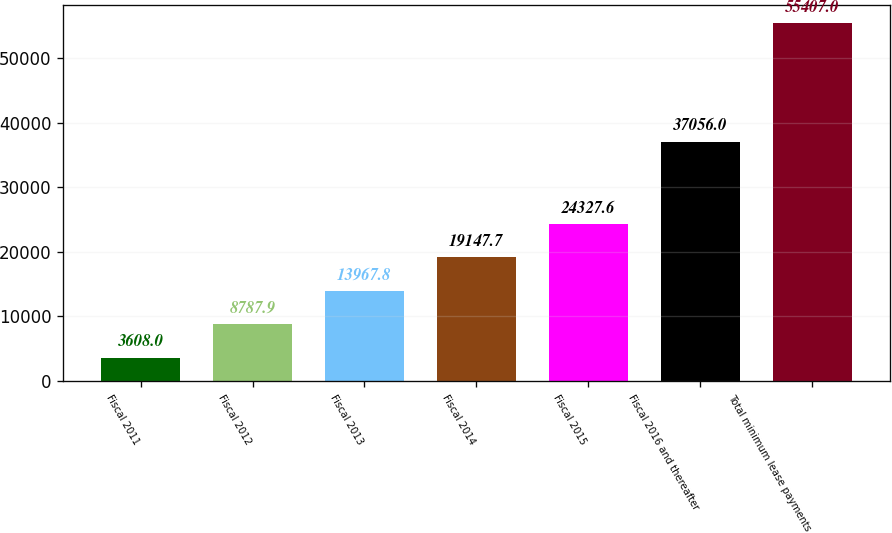<chart> <loc_0><loc_0><loc_500><loc_500><bar_chart><fcel>Fiscal 2011<fcel>Fiscal 2012<fcel>Fiscal 2013<fcel>Fiscal 2014<fcel>Fiscal 2015<fcel>Fiscal 2016 and thereafter<fcel>Total minimum lease payments<nl><fcel>3608<fcel>8787.9<fcel>13967.8<fcel>19147.7<fcel>24327.6<fcel>37056<fcel>55407<nl></chart> 